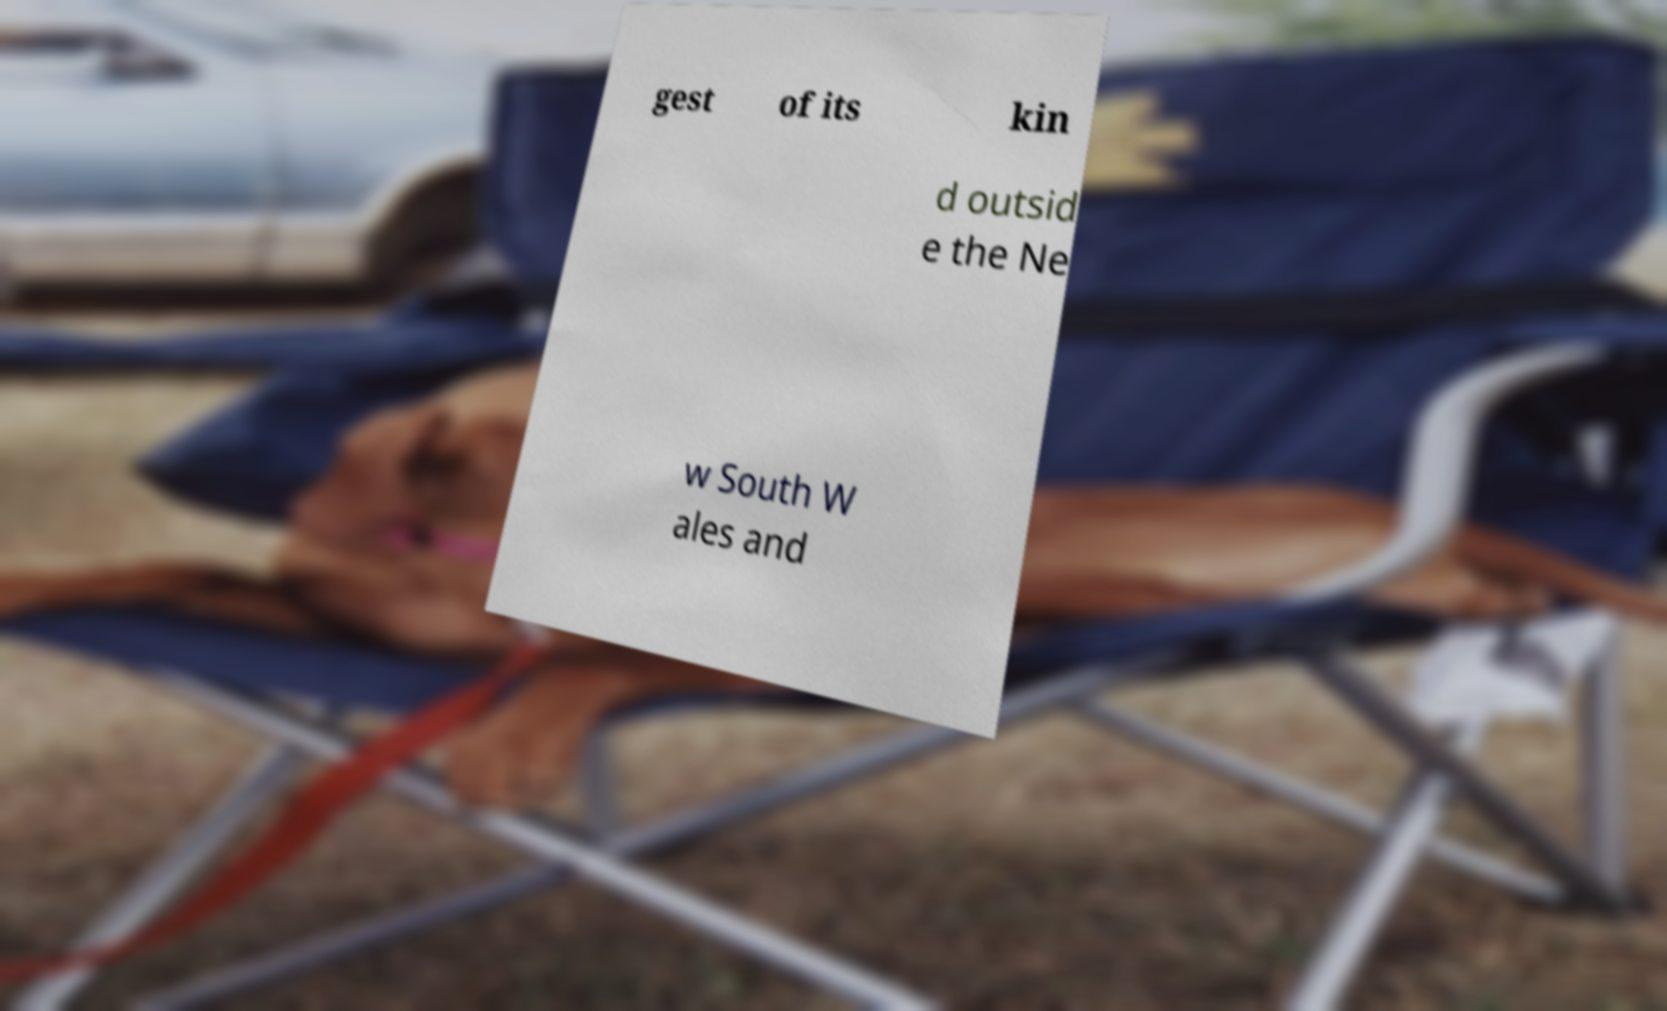For documentation purposes, I need the text within this image transcribed. Could you provide that? gest of its kin d outsid e the Ne w South W ales and 